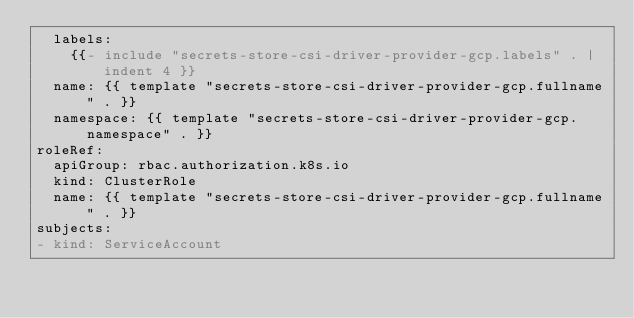Convert code to text. <code><loc_0><loc_0><loc_500><loc_500><_YAML_>  labels:
    {{- include "secrets-store-csi-driver-provider-gcp.labels" . | indent 4 }}
  name: {{ template "secrets-store-csi-driver-provider-gcp.fullname" . }}
  namespace: {{ template "secrets-store-csi-driver-provider-gcp.namespace" . }}
roleRef:
  apiGroup: rbac.authorization.k8s.io
  kind: ClusterRole
  name: {{ template "secrets-store-csi-driver-provider-gcp.fullname" . }}
subjects:
- kind: ServiceAccount</code> 